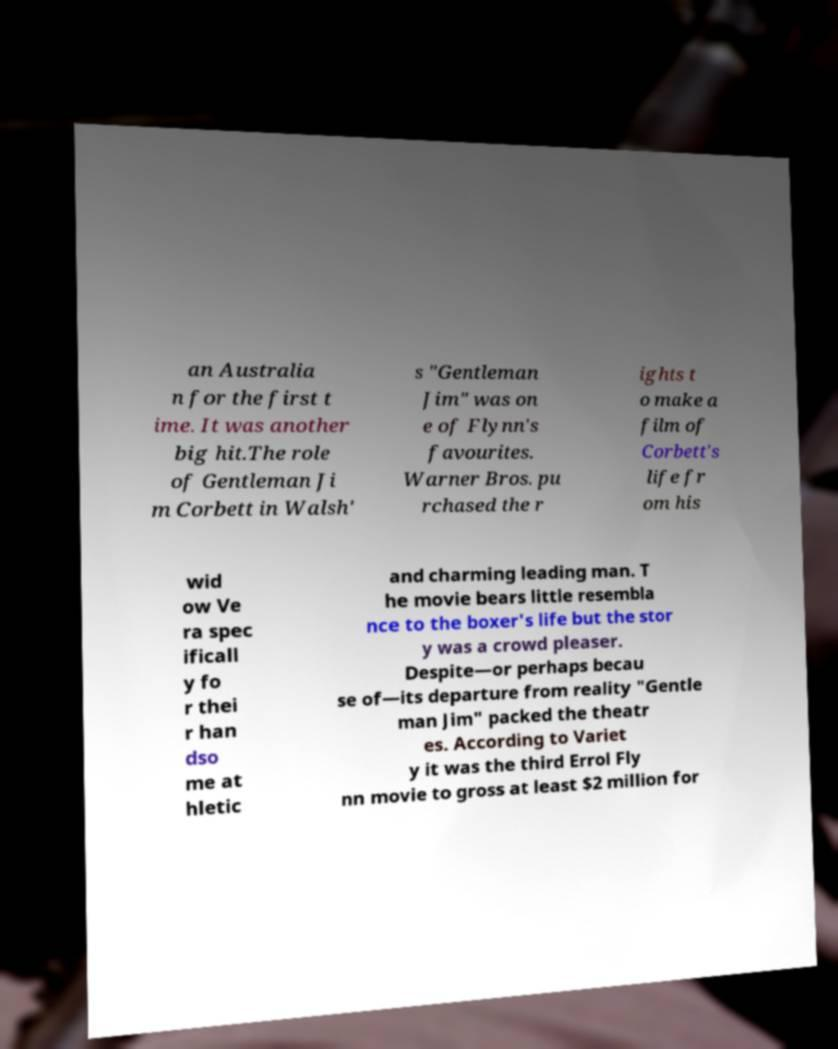Could you extract and type out the text from this image? an Australia n for the first t ime. It was another big hit.The role of Gentleman Ji m Corbett in Walsh' s "Gentleman Jim" was on e of Flynn's favourites. Warner Bros. pu rchased the r ights t o make a film of Corbett's life fr om his wid ow Ve ra spec ificall y fo r thei r han dso me at hletic and charming leading man. T he movie bears little resembla nce to the boxer's life but the stor y was a crowd pleaser. Despite—or perhaps becau se of—its departure from reality "Gentle man Jim" packed the theatr es. According to Variet y it was the third Errol Fly nn movie to gross at least $2 million for 